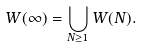<formula> <loc_0><loc_0><loc_500><loc_500>W ( \infty ) = \bigcup _ { N \geq 1 } W ( N ) .</formula> 